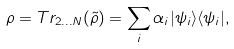<formula> <loc_0><loc_0><loc_500><loc_500>\rho = T r _ { 2 \dots N } ( \tilde { \rho } ) = \sum _ { i } \alpha _ { i } | \psi _ { i } \rangle \langle \psi _ { i } | ,</formula> 